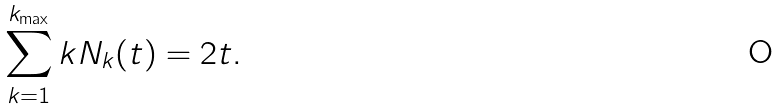Convert formula to latex. <formula><loc_0><loc_0><loc_500><loc_500>\sum _ { k = 1 } ^ { k _ { \max } } k N _ { k } ( t ) = 2 t .</formula> 